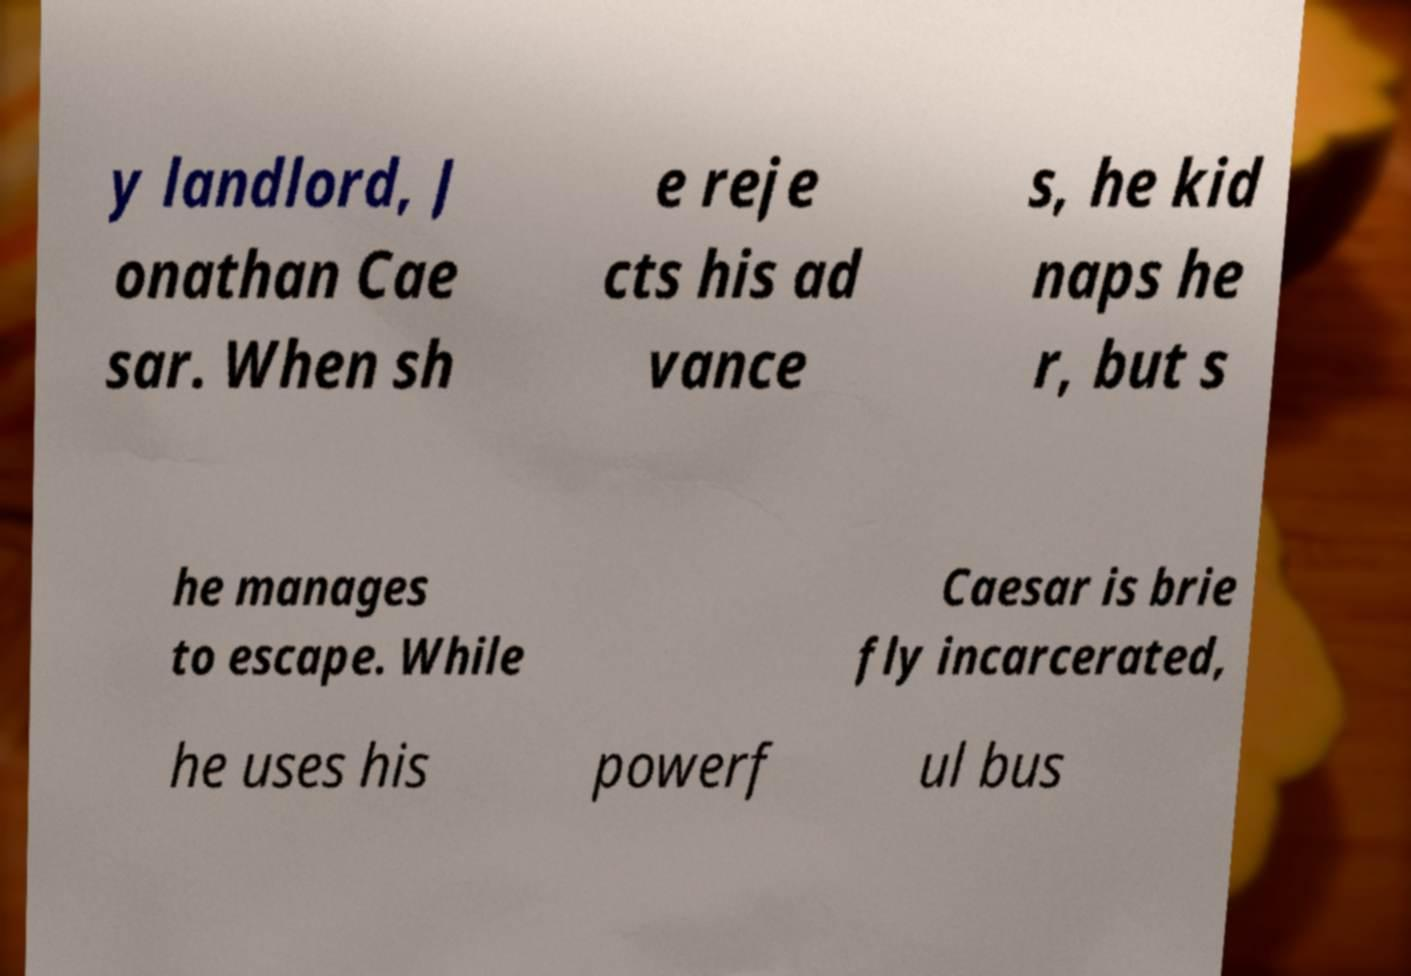There's text embedded in this image that I need extracted. Can you transcribe it verbatim? y landlord, J onathan Cae sar. When sh e reje cts his ad vance s, he kid naps he r, but s he manages to escape. While Caesar is brie fly incarcerated, he uses his powerf ul bus 